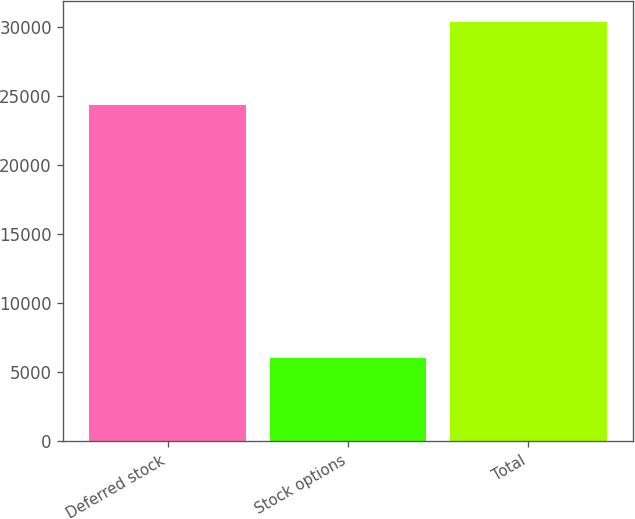<chart> <loc_0><loc_0><loc_500><loc_500><bar_chart><fcel>Deferred stock<fcel>Stock options<fcel>Total<nl><fcel>24318<fcel>6020<fcel>30338<nl></chart> 